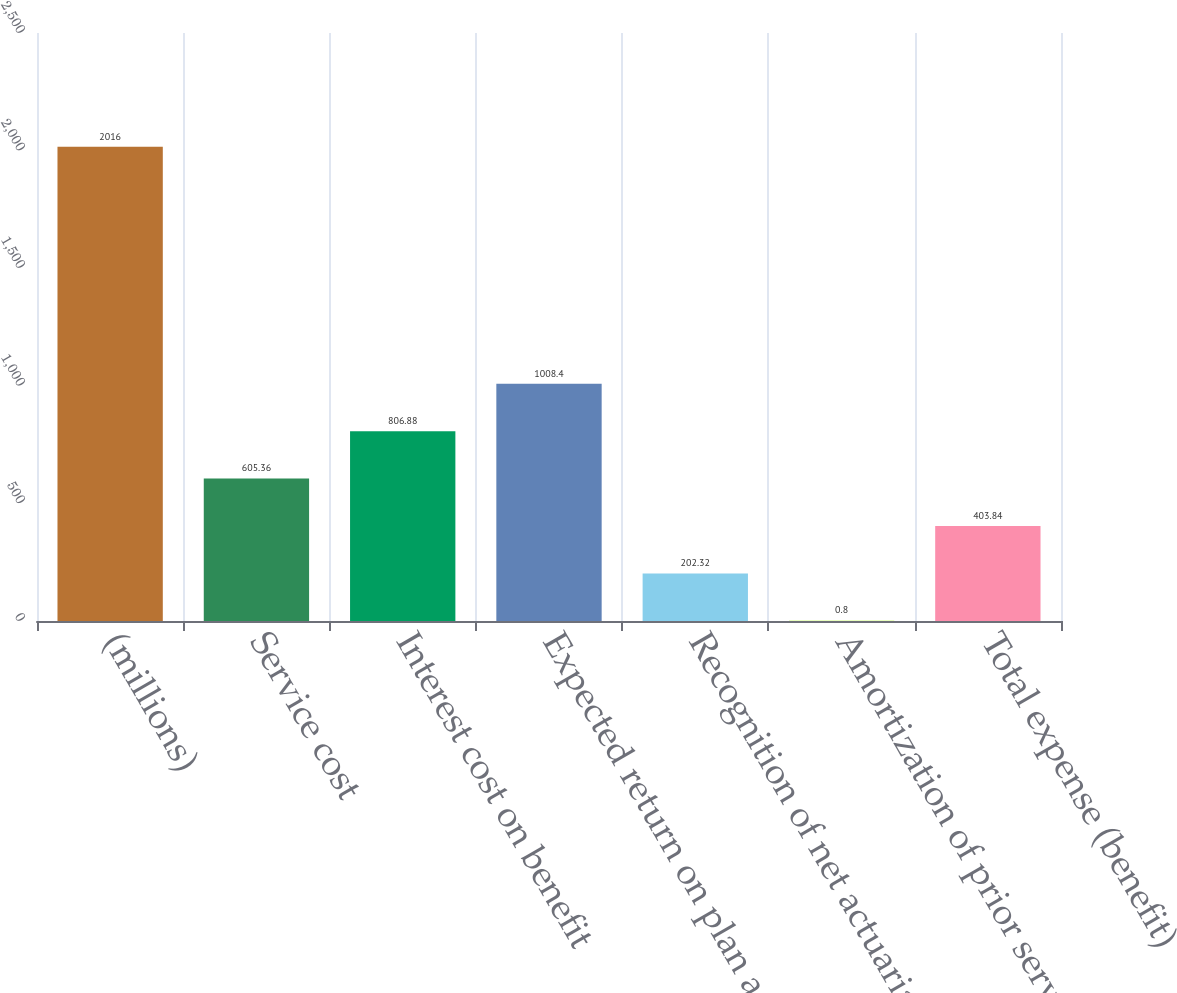Convert chart. <chart><loc_0><loc_0><loc_500><loc_500><bar_chart><fcel>(millions)<fcel>Service cost<fcel>Interest cost on benefit<fcel>Expected return on plan assets<fcel>Recognition of net actuarial<fcel>Amortization of prior service<fcel>Total expense (benefit)<nl><fcel>2016<fcel>605.36<fcel>806.88<fcel>1008.4<fcel>202.32<fcel>0.8<fcel>403.84<nl></chart> 